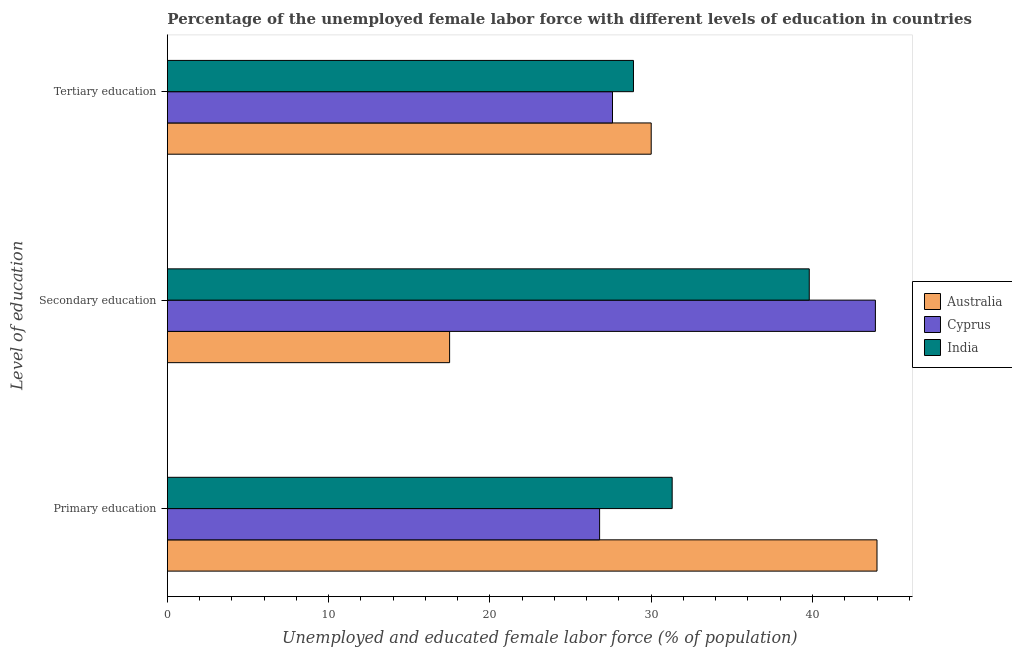How many different coloured bars are there?
Give a very brief answer. 3. Are the number of bars on each tick of the Y-axis equal?
Keep it short and to the point. Yes. How many bars are there on the 2nd tick from the bottom?
Provide a succinct answer. 3. What is the label of the 1st group of bars from the top?
Ensure brevity in your answer.  Tertiary education. What is the percentage of female labor force who received primary education in India?
Offer a terse response. 31.3. Across all countries, what is the maximum percentage of female labor force who received secondary education?
Ensure brevity in your answer.  43.9. Across all countries, what is the minimum percentage of female labor force who received tertiary education?
Offer a terse response. 27.6. In which country was the percentage of female labor force who received primary education minimum?
Offer a very short reply. Cyprus. What is the total percentage of female labor force who received secondary education in the graph?
Ensure brevity in your answer.  101.2. What is the difference between the percentage of female labor force who received tertiary education in Cyprus and that in Australia?
Give a very brief answer. -2.4. What is the difference between the percentage of female labor force who received secondary education in Australia and the percentage of female labor force who received primary education in Cyprus?
Provide a short and direct response. -9.3. What is the average percentage of female labor force who received primary education per country?
Give a very brief answer. 34.03. What is the difference between the percentage of female labor force who received primary education and percentage of female labor force who received secondary education in India?
Offer a very short reply. -8.5. In how many countries, is the percentage of female labor force who received primary education greater than 28 %?
Offer a very short reply. 2. What is the ratio of the percentage of female labor force who received primary education in Cyprus to that in Australia?
Provide a short and direct response. 0.61. Is the difference between the percentage of female labor force who received tertiary education in India and Australia greater than the difference between the percentage of female labor force who received primary education in India and Australia?
Offer a very short reply. Yes. What is the difference between the highest and the second highest percentage of female labor force who received tertiary education?
Give a very brief answer. 1.1. What is the difference between the highest and the lowest percentage of female labor force who received tertiary education?
Your answer should be very brief. 2.4. In how many countries, is the percentage of female labor force who received secondary education greater than the average percentage of female labor force who received secondary education taken over all countries?
Provide a short and direct response. 2. Is the sum of the percentage of female labor force who received primary education in Australia and India greater than the maximum percentage of female labor force who received secondary education across all countries?
Ensure brevity in your answer.  Yes. What does the 2nd bar from the bottom in Primary education represents?
Make the answer very short. Cyprus. How many bars are there?
Offer a terse response. 9. Where does the legend appear in the graph?
Provide a succinct answer. Center right. What is the title of the graph?
Your response must be concise. Percentage of the unemployed female labor force with different levels of education in countries. What is the label or title of the X-axis?
Offer a very short reply. Unemployed and educated female labor force (% of population). What is the label or title of the Y-axis?
Offer a terse response. Level of education. What is the Unemployed and educated female labor force (% of population) of Australia in Primary education?
Ensure brevity in your answer.  44. What is the Unemployed and educated female labor force (% of population) of Cyprus in Primary education?
Your answer should be compact. 26.8. What is the Unemployed and educated female labor force (% of population) of India in Primary education?
Offer a terse response. 31.3. What is the Unemployed and educated female labor force (% of population) of Cyprus in Secondary education?
Offer a terse response. 43.9. What is the Unemployed and educated female labor force (% of population) of India in Secondary education?
Give a very brief answer. 39.8. What is the Unemployed and educated female labor force (% of population) of Cyprus in Tertiary education?
Keep it short and to the point. 27.6. What is the Unemployed and educated female labor force (% of population) of India in Tertiary education?
Your answer should be compact. 28.9. Across all Level of education, what is the maximum Unemployed and educated female labor force (% of population) of Australia?
Keep it short and to the point. 44. Across all Level of education, what is the maximum Unemployed and educated female labor force (% of population) in Cyprus?
Your answer should be compact. 43.9. Across all Level of education, what is the maximum Unemployed and educated female labor force (% of population) in India?
Your answer should be compact. 39.8. Across all Level of education, what is the minimum Unemployed and educated female labor force (% of population) of Cyprus?
Your response must be concise. 26.8. Across all Level of education, what is the minimum Unemployed and educated female labor force (% of population) of India?
Keep it short and to the point. 28.9. What is the total Unemployed and educated female labor force (% of population) of Australia in the graph?
Offer a terse response. 91.5. What is the total Unemployed and educated female labor force (% of population) of Cyprus in the graph?
Make the answer very short. 98.3. What is the difference between the Unemployed and educated female labor force (% of population) in Australia in Primary education and that in Secondary education?
Your answer should be very brief. 26.5. What is the difference between the Unemployed and educated female labor force (% of population) of Cyprus in Primary education and that in Secondary education?
Make the answer very short. -17.1. What is the difference between the Unemployed and educated female labor force (% of population) in India in Primary education and that in Secondary education?
Your answer should be very brief. -8.5. What is the difference between the Unemployed and educated female labor force (% of population) of Australia in Primary education and that in Tertiary education?
Keep it short and to the point. 14. What is the difference between the Unemployed and educated female labor force (% of population) in Cyprus in Primary education and that in Tertiary education?
Your answer should be very brief. -0.8. What is the difference between the Unemployed and educated female labor force (% of population) in Australia in Primary education and the Unemployed and educated female labor force (% of population) in India in Tertiary education?
Your response must be concise. 15.1. What is the difference between the Unemployed and educated female labor force (% of population) in Australia in Secondary education and the Unemployed and educated female labor force (% of population) in Cyprus in Tertiary education?
Your answer should be compact. -10.1. What is the difference between the Unemployed and educated female labor force (% of population) in Australia in Secondary education and the Unemployed and educated female labor force (% of population) in India in Tertiary education?
Make the answer very short. -11.4. What is the difference between the Unemployed and educated female labor force (% of population) in Cyprus in Secondary education and the Unemployed and educated female labor force (% of population) in India in Tertiary education?
Provide a short and direct response. 15. What is the average Unemployed and educated female labor force (% of population) in Australia per Level of education?
Give a very brief answer. 30.5. What is the average Unemployed and educated female labor force (% of population) in Cyprus per Level of education?
Give a very brief answer. 32.77. What is the average Unemployed and educated female labor force (% of population) of India per Level of education?
Ensure brevity in your answer.  33.33. What is the difference between the Unemployed and educated female labor force (% of population) of Australia and Unemployed and educated female labor force (% of population) of Cyprus in Primary education?
Offer a terse response. 17.2. What is the difference between the Unemployed and educated female labor force (% of population) in Australia and Unemployed and educated female labor force (% of population) in India in Primary education?
Offer a very short reply. 12.7. What is the difference between the Unemployed and educated female labor force (% of population) in Cyprus and Unemployed and educated female labor force (% of population) in India in Primary education?
Your response must be concise. -4.5. What is the difference between the Unemployed and educated female labor force (% of population) in Australia and Unemployed and educated female labor force (% of population) in Cyprus in Secondary education?
Your response must be concise. -26.4. What is the difference between the Unemployed and educated female labor force (% of population) of Australia and Unemployed and educated female labor force (% of population) of India in Secondary education?
Your answer should be very brief. -22.3. What is the difference between the Unemployed and educated female labor force (% of population) of Australia and Unemployed and educated female labor force (% of population) of Cyprus in Tertiary education?
Your response must be concise. 2.4. What is the ratio of the Unemployed and educated female labor force (% of population) in Australia in Primary education to that in Secondary education?
Offer a very short reply. 2.51. What is the ratio of the Unemployed and educated female labor force (% of population) in Cyprus in Primary education to that in Secondary education?
Your answer should be compact. 0.61. What is the ratio of the Unemployed and educated female labor force (% of population) of India in Primary education to that in Secondary education?
Ensure brevity in your answer.  0.79. What is the ratio of the Unemployed and educated female labor force (% of population) in Australia in Primary education to that in Tertiary education?
Your answer should be compact. 1.47. What is the ratio of the Unemployed and educated female labor force (% of population) of Cyprus in Primary education to that in Tertiary education?
Ensure brevity in your answer.  0.97. What is the ratio of the Unemployed and educated female labor force (% of population) of India in Primary education to that in Tertiary education?
Ensure brevity in your answer.  1.08. What is the ratio of the Unemployed and educated female labor force (% of population) in Australia in Secondary education to that in Tertiary education?
Your response must be concise. 0.58. What is the ratio of the Unemployed and educated female labor force (% of population) of Cyprus in Secondary education to that in Tertiary education?
Make the answer very short. 1.59. What is the ratio of the Unemployed and educated female labor force (% of population) in India in Secondary education to that in Tertiary education?
Ensure brevity in your answer.  1.38. What is the difference between the highest and the second highest Unemployed and educated female labor force (% of population) in Australia?
Keep it short and to the point. 14. What is the difference between the highest and the second highest Unemployed and educated female labor force (% of population) of Cyprus?
Offer a terse response. 16.3. What is the difference between the highest and the lowest Unemployed and educated female labor force (% of population) in Australia?
Make the answer very short. 26.5. 